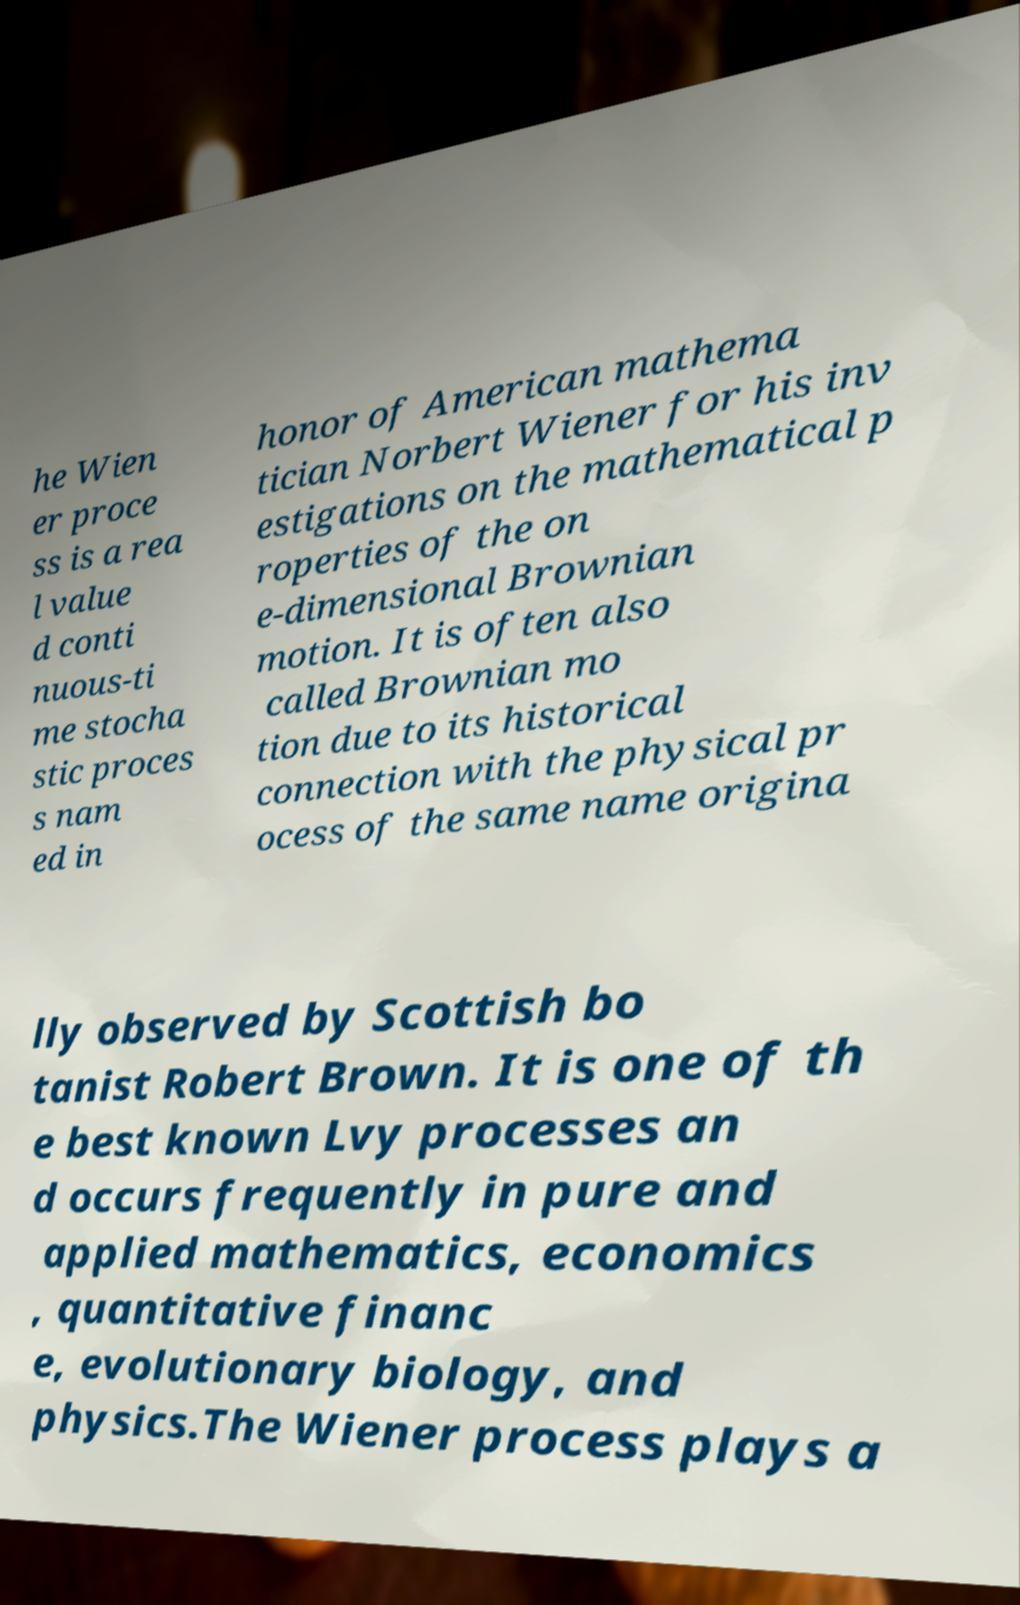Could you assist in decoding the text presented in this image and type it out clearly? he Wien er proce ss is a rea l value d conti nuous-ti me stocha stic proces s nam ed in honor of American mathema tician Norbert Wiener for his inv estigations on the mathematical p roperties of the on e-dimensional Brownian motion. It is often also called Brownian mo tion due to its historical connection with the physical pr ocess of the same name origina lly observed by Scottish bo tanist Robert Brown. It is one of th e best known Lvy processes an d occurs frequently in pure and applied mathematics, economics , quantitative financ e, evolutionary biology, and physics.The Wiener process plays a 